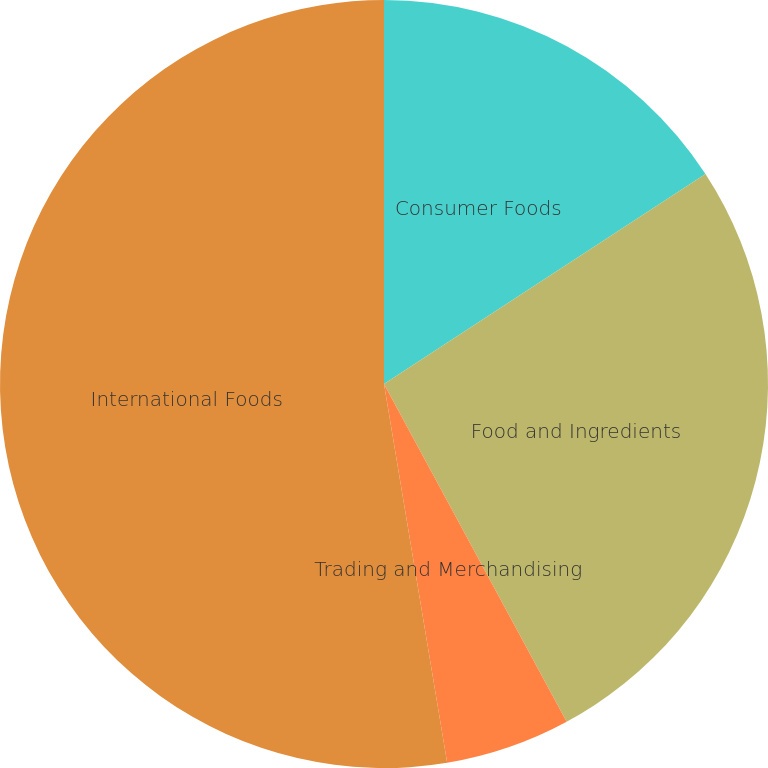Convert chart. <chart><loc_0><loc_0><loc_500><loc_500><pie_chart><fcel>Consumer Foods<fcel>Food and Ingredients<fcel>Trading and Merchandising<fcel>International Foods<nl><fcel>15.79%<fcel>26.32%<fcel>5.26%<fcel>52.63%<nl></chart> 